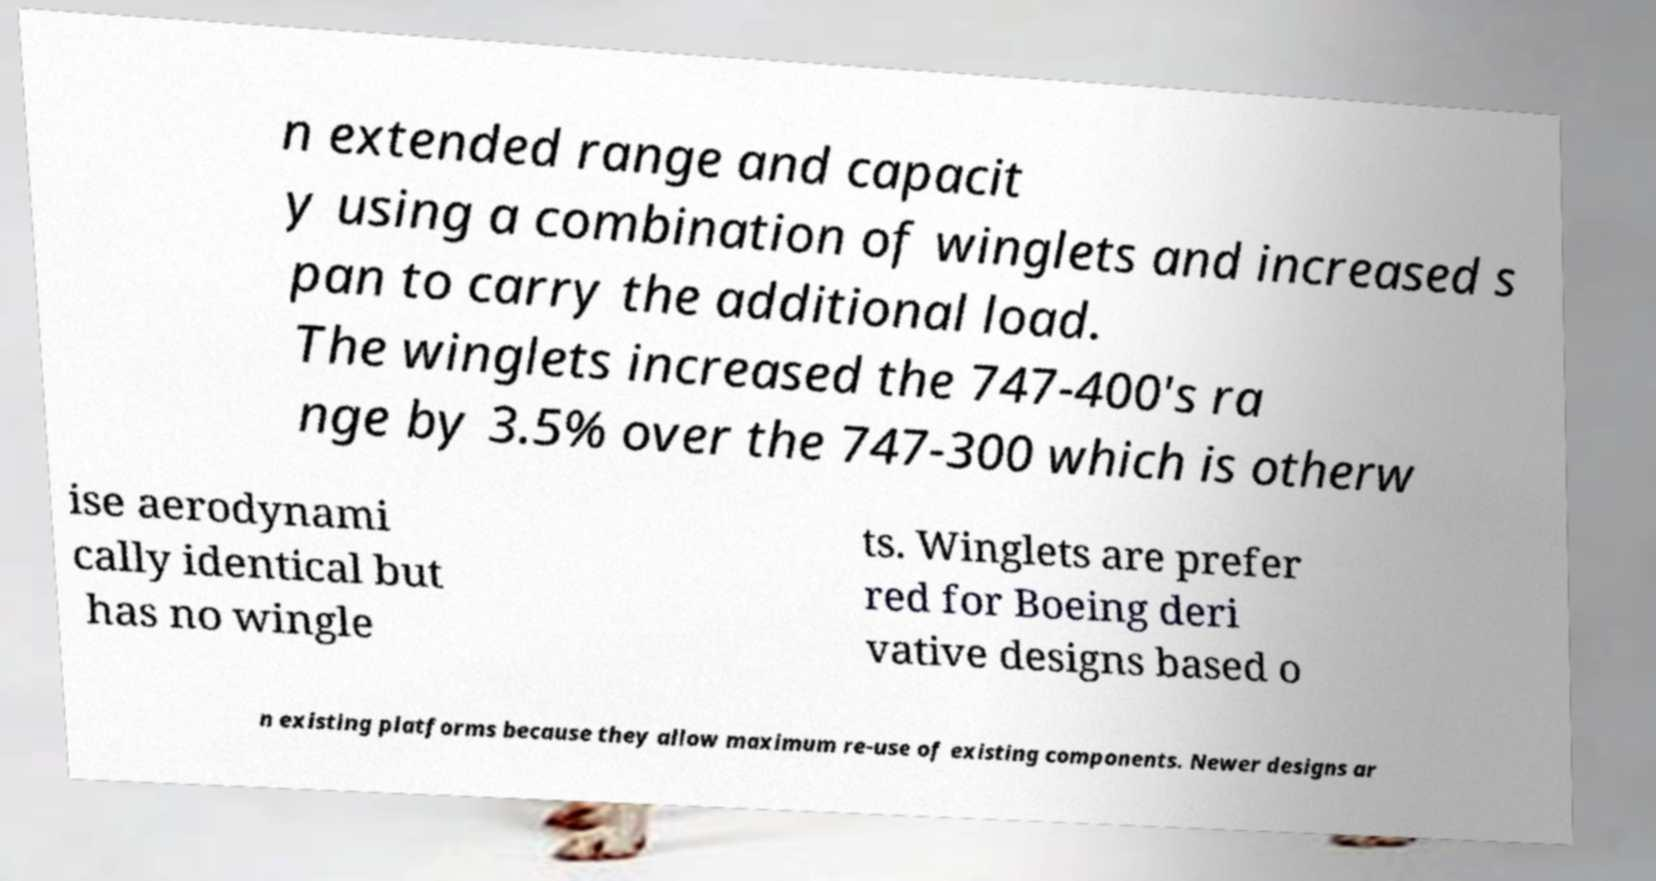There's text embedded in this image that I need extracted. Can you transcribe it verbatim? n extended range and capacit y using a combination of winglets and increased s pan to carry the additional load. The winglets increased the 747-400's ra nge by 3.5% over the 747-300 which is otherw ise aerodynami cally identical but has no wingle ts. Winglets are prefer red for Boeing deri vative designs based o n existing platforms because they allow maximum re-use of existing components. Newer designs ar 